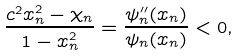Convert formula to latex. <formula><loc_0><loc_0><loc_500><loc_500>\frac { c ^ { 2 } x _ { n } ^ { 2 } - \chi _ { n } } { 1 - x _ { n } ^ { 2 } } = \frac { \psi _ { n } ^ { \prime \prime } ( x _ { n } ) } { \psi _ { n } ( x _ { n } ) } < 0 ,</formula> 